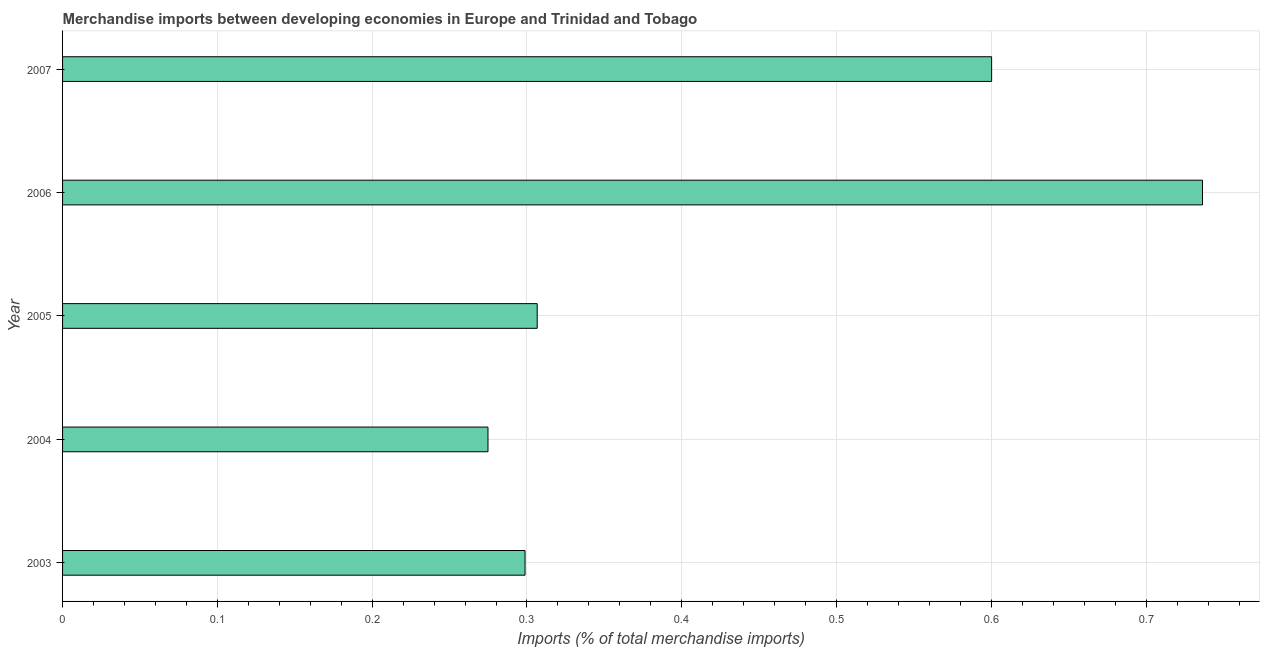What is the title of the graph?
Provide a short and direct response. Merchandise imports between developing economies in Europe and Trinidad and Tobago. What is the label or title of the X-axis?
Offer a terse response. Imports (% of total merchandise imports). What is the merchandise imports in 2007?
Provide a short and direct response. 0.6. Across all years, what is the maximum merchandise imports?
Offer a terse response. 0.74. Across all years, what is the minimum merchandise imports?
Provide a short and direct response. 0.27. In which year was the merchandise imports maximum?
Your answer should be very brief. 2006. What is the sum of the merchandise imports?
Your answer should be very brief. 2.22. What is the difference between the merchandise imports in 2004 and 2006?
Provide a succinct answer. -0.46. What is the average merchandise imports per year?
Offer a very short reply. 0.44. What is the median merchandise imports?
Your answer should be very brief. 0.31. What is the ratio of the merchandise imports in 2005 to that in 2007?
Provide a short and direct response. 0.51. Is the merchandise imports in 2004 less than that in 2007?
Ensure brevity in your answer.  Yes. Is the difference between the merchandise imports in 2004 and 2005 greater than the difference between any two years?
Provide a succinct answer. No. What is the difference between the highest and the second highest merchandise imports?
Your answer should be compact. 0.14. What is the difference between the highest and the lowest merchandise imports?
Your answer should be very brief. 0.46. How many bars are there?
Provide a succinct answer. 5. Are all the bars in the graph horizontal?
Your response must be concise. Yes. What is the difference between two consecutive major ticks on the X-axis?
Offer a terse response. 0.1. What is the Imports (% of total merchandise imports) in 2003?
Keep it short and to the point. 0.3. What is the Imports (% of total merchandise imports) in 2004?
Your answer should be very brief. 0.27. What is the Imports (% of total merchandise imports) of 2005?
Offer a terse response. 0.31. What is the Imports (% of total merchandise imports) in 2006?
Give a very brief answer. 0.74. What is the Imports (% of total merchandise imports) of 2007?
Your answer should be very brief. 0.6. What is the difference between the Imports (% of total merchandise imports) in 2003 and 2004?
Ensure brevity in your answer.  0.02. What is the difference between the Imports (% of total merchandise imports) in 2003 and 2005?
Your response must be concise. -0.01. What is the difference between the Imports (% of total merchandise imports) in 2003 and 2006?
Keep it short and to the point. -0.44. What is the difference between the Imports (% of total merchandise imports) in 2003 and 2007?
Keep it short and to the point. -0.3. What is the difference between the Imports (% of total merchandise imports) in 2004 and 2005?
Ensure brevity in your answer.  -0.03. What is the difference between the Imports (% of total merchandise imports) in 2004 and 2006?
Keep it short and to the point. -0.46. What is the difference between the Imports (% of total merchandise imports) in 2004 and 2007?
Your answer should be very brief. -0.33. What is the difference between the Imports (% of total merchandise imports) in 2005 and 2006?
Give a very brief answer. -0.43. What is the difference between the Imports (% of total merchandise imports) in 2005 and 2007?
Your answer should be compact. -0.29. What is the difference between the Imports (% of total merchandise imports) in 2006 and 2007?
Give a very brief answer. 0.14. What is the ratio of the Imports (% of total merchandise imports) in 2003 to that in 2004?
Offer a very short reply. 1.09. What is the ratio of the Imports (% of total merchandise imports) in 2003 to that in 2006?
Make the answer very short. 0.41. What is the ratio of the Imports (% of total merchandise imports) in 2003 to that in 2007?
Offer a very short reply. 0.5. What is the ratio of the Imports (% of total merchandise imports) in 2004 to that in 2005?
Your answer should be very brief. 0.9. What is the ratio of the Imports (% of total merchandise imports) in 2004 to that in 2006?
Keep it short and to the point. 0.37. What is the ratio of the Imports (% of total merchandise imports) in 2004 to that in 2007?
Your response must be concise. 0.46. What is the ratio of the Imports (% of total merchandise imports) in 2005 to that in 2006?
Your answer should be very brief. 0.42. What is the ratio of the Imports (% of total merchandise imports) in 2005 to that in 2007?
Make the answer very short. 0.51. What is the ratio of the Imports (% of total merchandise imports) in 2006 to that in 2007?
Provide a short and direct response. 1.23. 